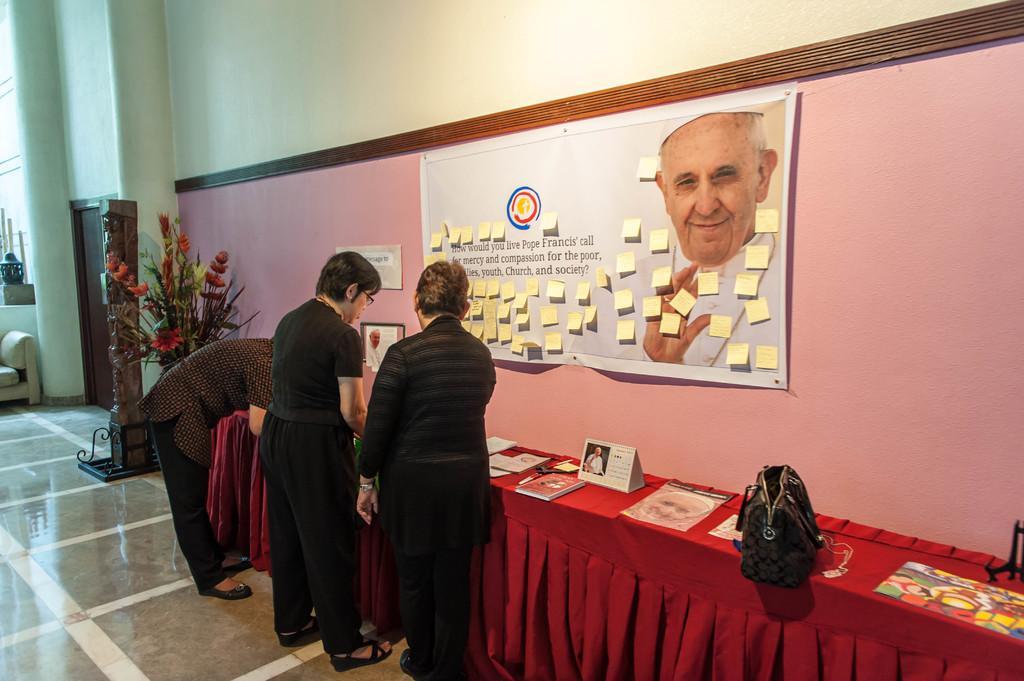Can you describe this image briefly? In this image i can see three persons standing at the background i can see few books, a bag on a table, a banner on a wall, a small flower pot,a door and a wall. 